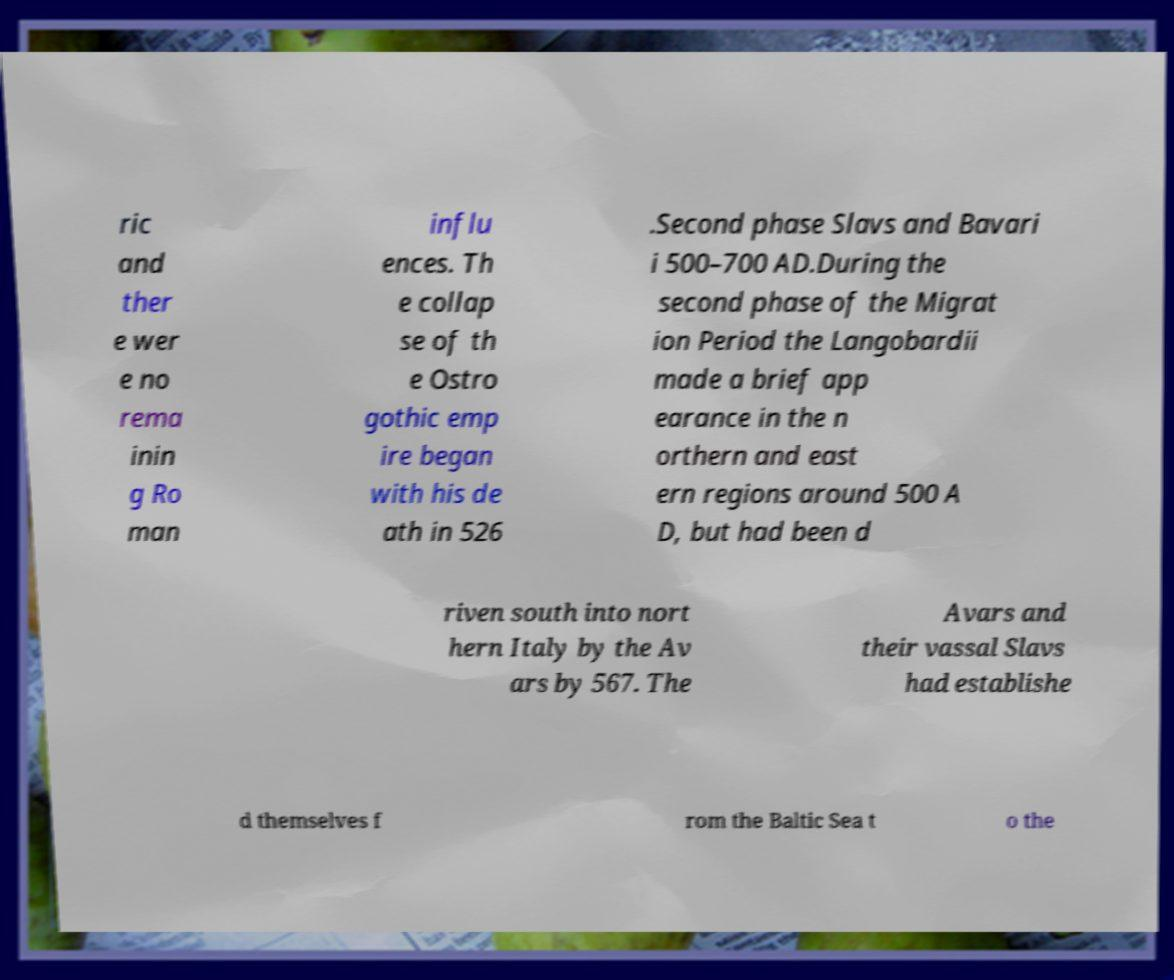Could you assist in decoding the text presented in this image and type it out clearly? ric and ther e wer e no rema inin g Ro man influ ences. Th e collap se of th e Ostro gothic emp ire began with his de ath in 526 .Second phase Slavs and Bavari i 500–700 AD.During the second phase of the Migrat ion Period the Langobardii made a brief app earance in the n orthern and east ern regions around 500 A D, but had been d riven south into nort hern Italy by the Av ars by 567. The Avars and their vassal Slavs had establishe d themselves f rom the Baltic Sea t o the 